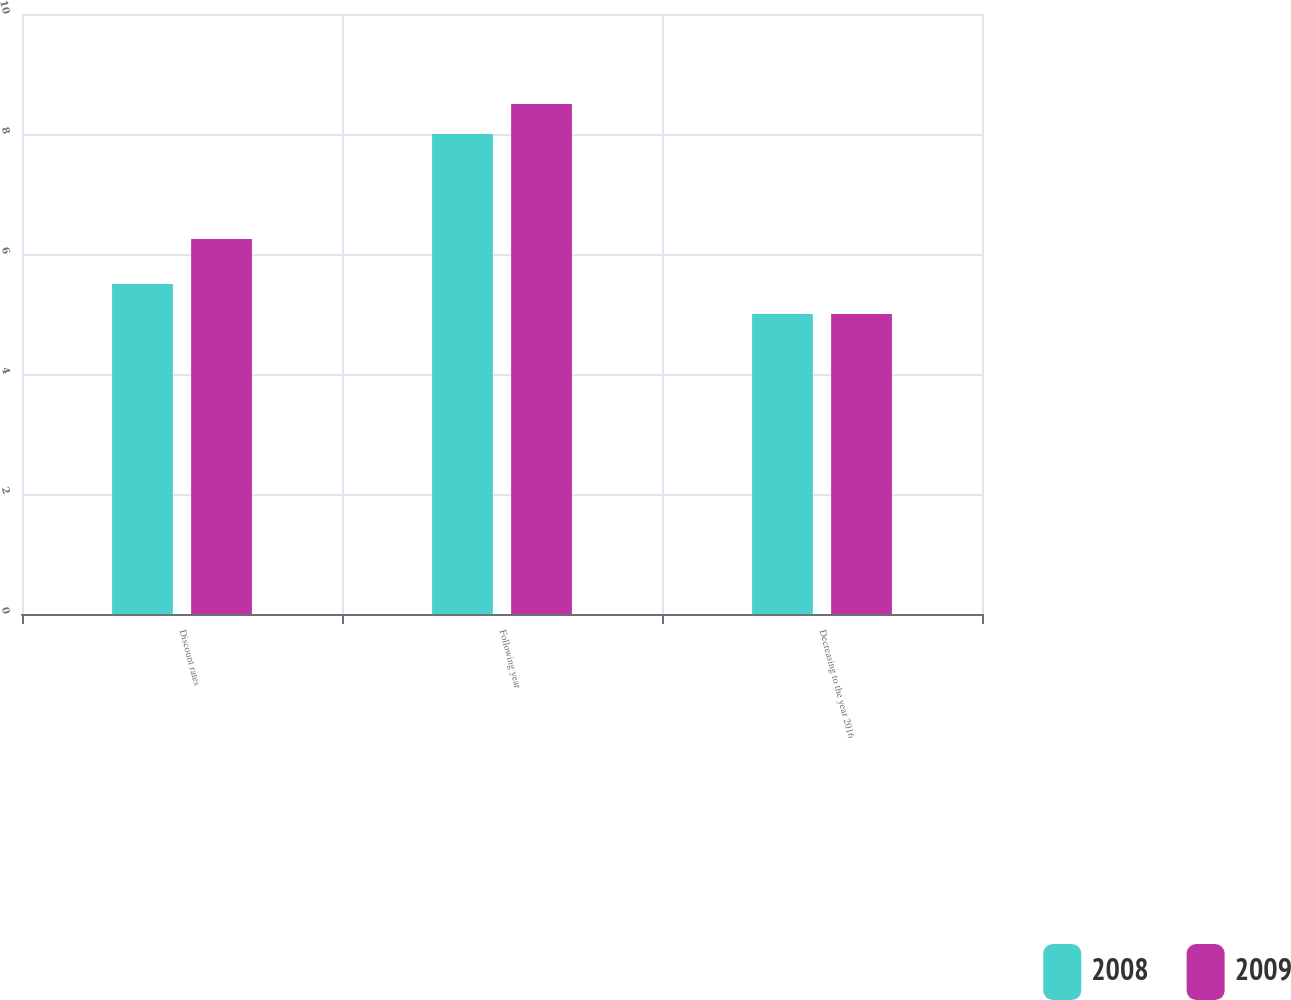<chart> <loc_0><loc_0><loc_500><loc_500><stacked_bar_chart><ecel><fcel>Discount rates<fcel>Following year<fcel>Decreasing to the year 2016<nl><fcel>2008<fcel>5.5<fcel>8<fcel>5<nl><fcel>2009<fcel>6.25<fcel>8.5<fcel>5<nl></chart> 